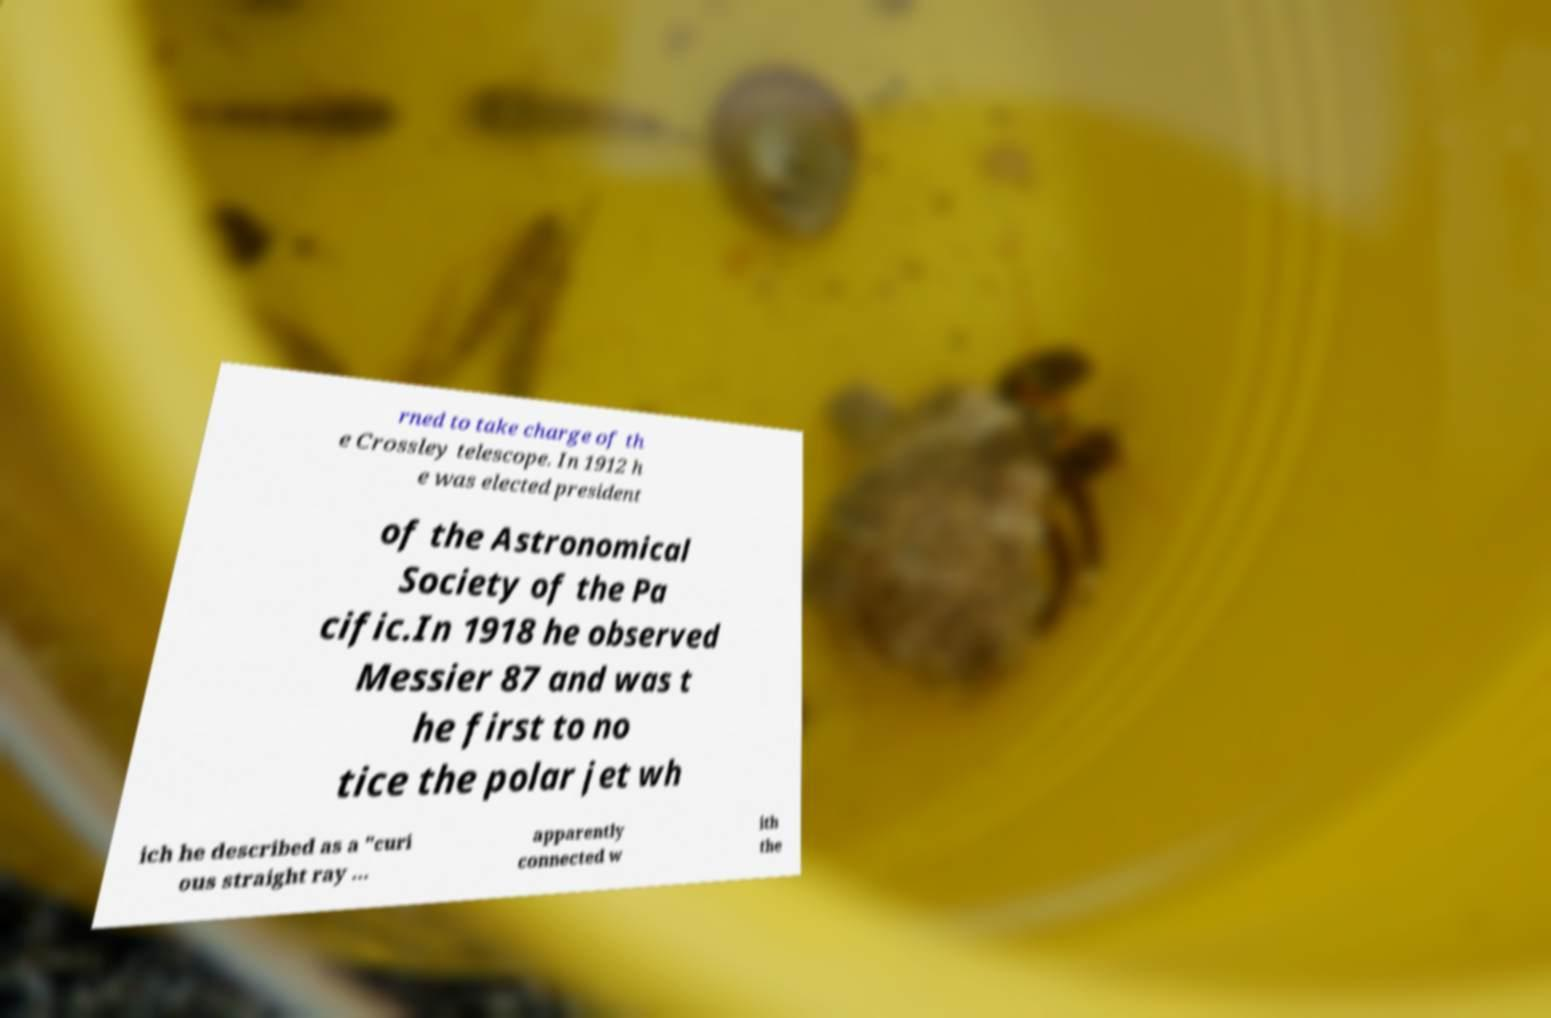Please identify and transcribe the text found in this image. rned to take charge of th e Crossley telescope. In 1912 h e was elected president of the Astronomical Society of the Pa cific.In 1918 he observed Messier 87 and was t he first to no tice the polar jet wh ich he described as a "curi ous straight ray ... apparently connected w ith the 